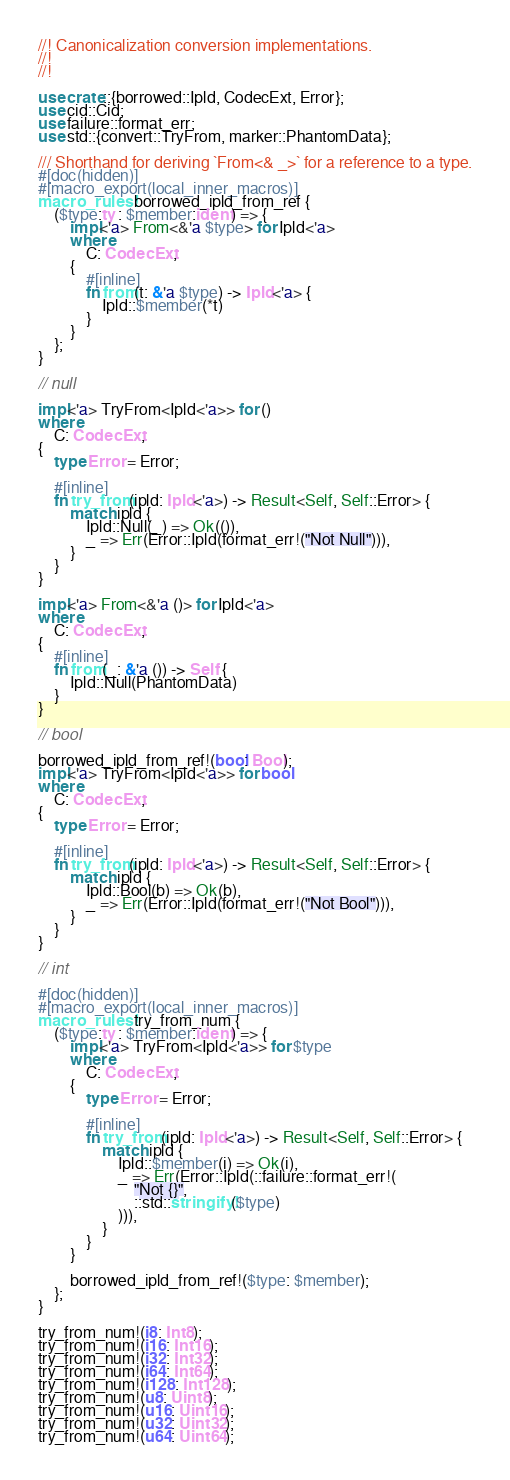Convert code to text. <code><loc_0><loc_0><loc_500><loc_500><_Rust_>//! Canonicalization conversion implementations.
//!
//!

use crate::{borrowed::Ipld, CodecExt, Error};
use cid::Cid;
use failure::format_err;
use std::{convert::TryFrom, marker::PhantomData};

/// Shorthand for deriving `From<& _>` for a reference to a type.
#[doc(hidden)]
#[macro_export(local_inner_macros)]
macro_rules! borrowed_ipld_from_ref {
    ($type:ty : $member:ident) => {
        impl<'a> From<&'a $type> for Ipld<'a>
        where
            C: CodecExt,
        {
            #[inline]
            fn from(t: &'a $type) -> Ipld<'a> {
                Ipld::$member(*t)
            }
        }
    };
}

// null

impl<'a> TryFrom<Ipld<'a>> for ()
where
    C: CodecExt,
{
    type Error = Error;

    #[inline]
    fn try_from(ipld: Ipld<'a>) -> Result<Self, Self::Error> {
        match ipld {
            Ipld::Null(_) => Ok(()),
            _ => Err(Error::Ipld(format_err!("Not Null"))),
        }
    }
}

impl<'a> From<&'a ()> for Ipld<'a>
where
    C: CodecExt,
{
    #[inline]
    fn from(_: &'a ()) -> Self {
        Ipld::Null(PhantomData)
    }
}

// bool

borrowed_ipld_from_ref!(bool: Bool);
impl<'a> TryFrom<Ipld<'a>> for bool
where
    C: CodecExt,
{
    type Error = Error;

    #[inline]
    fn try_from(ipld: Ipld<'a>) -> Result<Self, Self::Error> {
        match ipld {
            Ipld::Bool(b) => Ok(b),
            _ => Err(Error::Ipld(format_err!("Not Bool"))),
        }
    }
}

// int

#[doc(hidden)]
#[macro_export(local_inner_macros)]
macro_rules! try_from_num {
    ($type:ty : $member:ident) => {
        impl<'a> TryFrom<Ipld<'a>> for $type
        where
            C: CodecExt,
        {
            type Error = Error;

            #[inline]
            fn try_from(ipld: Ipld<'a>) -> Result<Self, Self::Error> {
                match ipld {
                    Ipld::$member(i) => Ok(i),
                    _ => Err(Error::Ipld(::failure::format_err!(
                        "Not {}",
                        ::std::stringify!($type)
                    ))),
                }
            }
        }

        borrowed_ipld_from_ref!($type: $member);
    };
}

try_from_num!(i8: Int8);
try_from_num!(i16: Int16);
try_from_num!(i32: Int32);
try_from_num!(i64: Int64);
try_from_num!(i128: Int128);
try_from_num!(u8: Uint8);
try_from_num!(u16: Uint16);
try_from_num!(u32: Uint32);
try_from_num!(u64: Uint64);</code> 